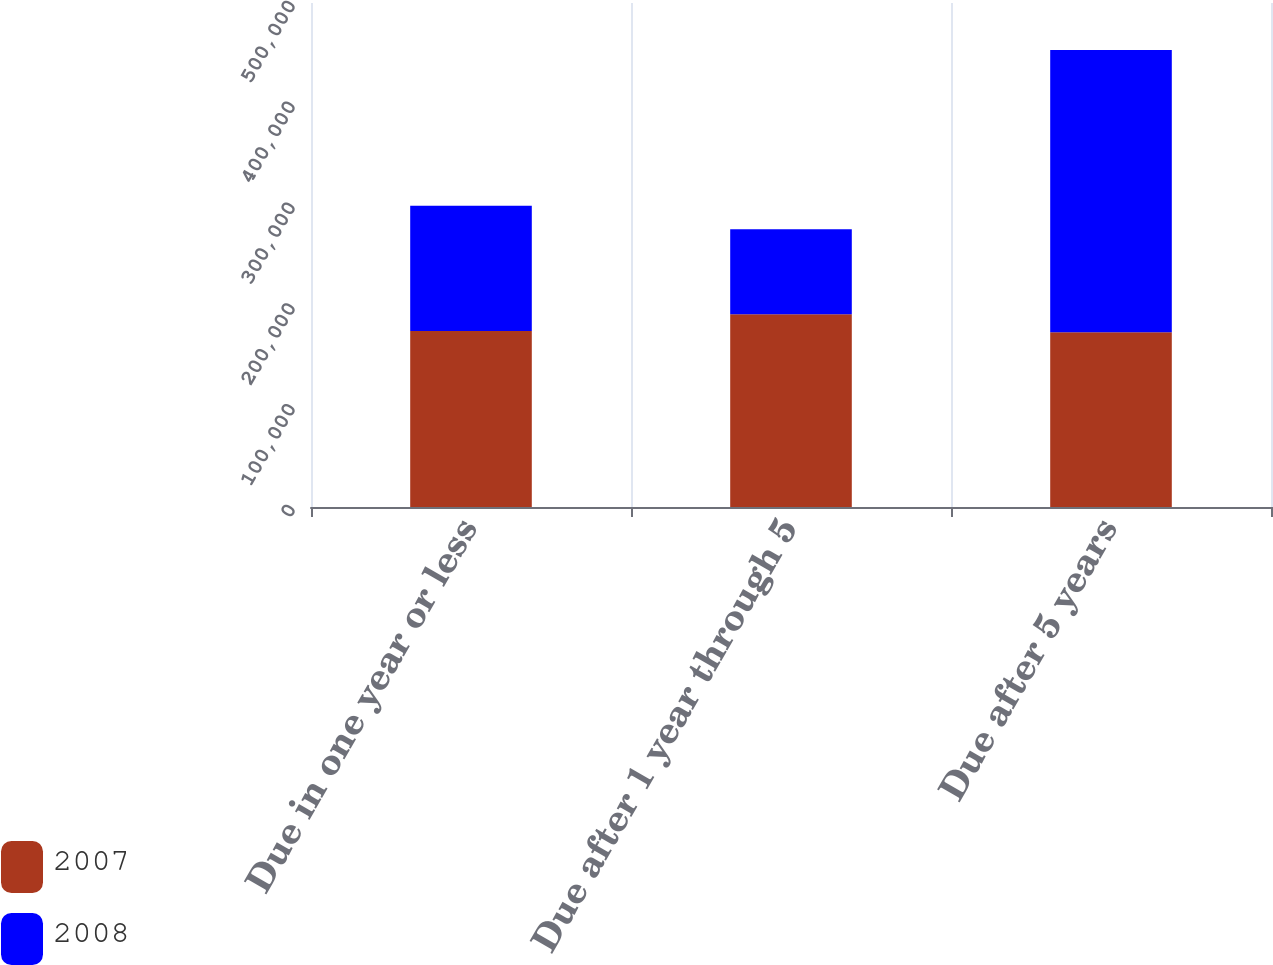Convert chart to OTSL. <chart><loc_0><loc_0><loc_500><loc_500><stacked_bar_chart><ecel><fcel>Due in one year or less<fcel>Due after 1 year through 5<fcel>Due after 5 years<nl><fcel>2007<fcel>174710<fcel>191337<fcel>173437<nl><fcel>2008<fcel>124243<fcel>84237<fcel>279950<nl></chart> 